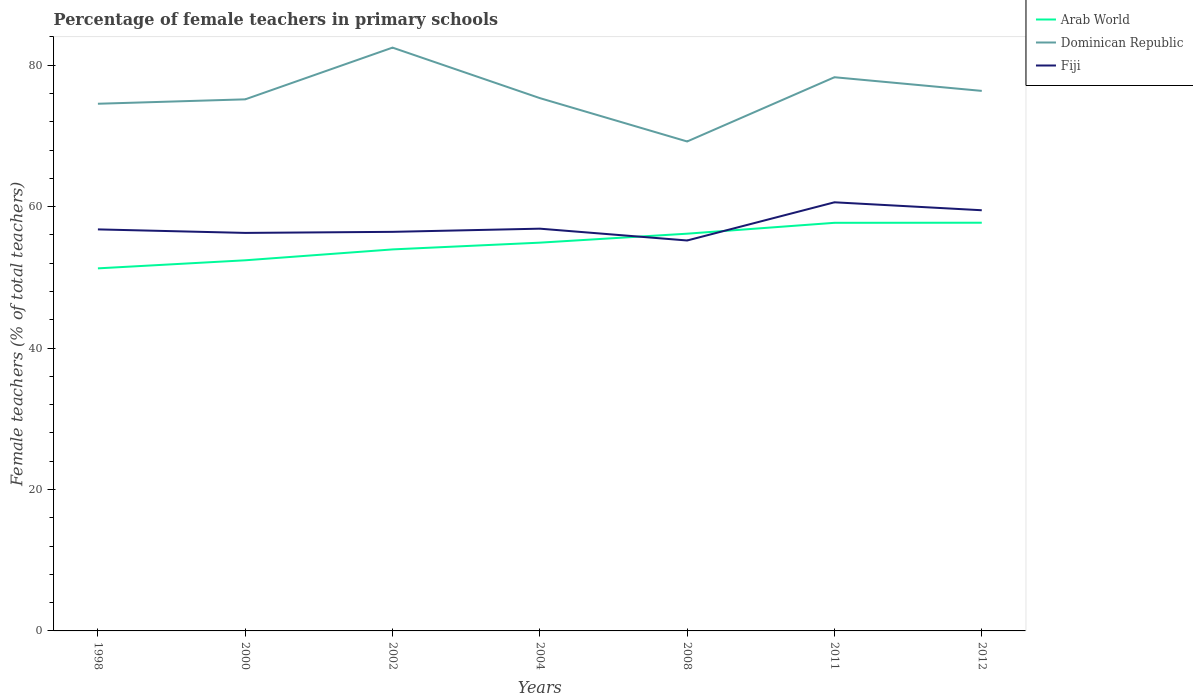How many different coloured lines are there?
Your answer should be compact. 3. Is the number of lines equal to the number of legend labels?
Provide a succinct answer. Yes. Across all years, what is the maximum percentage of female teachers in Arab World?
Make the answer very short. 51.27. In which year was the percentage of female teachers in Dominican Republic maximum?
Your answer should be very brief. 2008. What is the total percentage of female teachers in Dominican Republic in the graph?
Your answer should be very brief. -1.02. What is the difference between the highest and the second highest percentage of female teachers in Fiji?
Make the answer very short. 5.4. Is the percentage of female teachers in Arab World strictly greater than the percentage of female teachers in Dominican Republic over the years?
Make the answer very short. Yes. What is the difference between two consecutive major ticks on the Y-axis?
Offer a very short reply. 20. Does the graph contain any zero values?
Provide a succinct answer. No. Does the graph contain grids?
Your answer should be very brief. No. How many legend labels are there?
Provide a short and direct response. 3. What is the title of the graph?
Your answer should be very brief. Percentage of female teachers in primary schools. Does "Denmark" appear as one of the legend labels in the graph?
Make the answer very short. No. What is the label or title of the X-axis?
Your response must be concise. Years. What is the label or title of the Y-axis?
Your answer should be very brief. Female teachers (% of total teachers). What is the Female teachers (% of total teachers) of Arab World in 1998?
Provide a succinct answer. 51.27. What is the Female teachers (% of total teachers) in Dominican Republic in 1998?
Offer a very short reply. 74.56. What is the Female teachers (% of total teachers) of Fiji in 1998?
Your response must be concise. 56.79. What is the Female teachers (% of total teachers) in Arab World in 2000?
Offer a terse response. 52.42. What is the Female teachers (% of total teachers) of Dominican Republic in 2000?
Provide a succinct answer. 75.18. What is the Female teachers (% of total teachers) in Fiji in 2000?
Your answer should be very brief. 56.29. What is the Female teachers (% of total teachers) in Arab World in 2002?
Your answer should be compact. 53.95. What is the Female teachers (% of total teachers) of Dominican Republic in 2002?
Keep it short and to the point. 82.49. What is the Female teachers (% of total teachers) in Fiji in 2002?
Give a very brief answer. 56.44. What is the Female teachers (% of total teachers) of Arab World in 2004?
Your answer should be compact. 54.91. What is the Female teachers (% of total teachers) of Dominican Republic in 2004?
Provide a short and direct response. 75.35. What is the Female teachers (% of total teachers) of Fiji in 2004?
Provide a succinct answer. 56.89. What is the Female teachers (% of total teachers) in Arab World in 2008?
Offer a very short reply. 56.18. What is the Female teachers (% of total teachers) of Dominican Republic in 2008?
Give a very brief answer. 69.22. What is the Female teachers (% of total teachers) of Fiji in 2008?
Provide a short and direct response. 55.22. What is the Female teachers (% of total teachers) of Arab World in 2011?
Your response must be concise. 57.72. What is the Female teachers (% of total teachers) in Dominican Republic in 2011?
Give a very brief answer. 78.31. What is the Female teachers (% of total teachers) of Fiji in 2011?
Your answer should be very brief. 60.62. What is the Female teachers (% of total teachers) of Arab World in 2012?
Your answer should be very brief. 57.73. What is the Female teachers (% of total teachers) of Dominican Republic in 2012?
Your answer should be compact. 76.37. What is the Female teachers (% of total teachers) of Fiji in 2012?
Provide a succinct answer. 59.49. Across all years, what is the maximum Female teachers (% of total teachers) of Arab World?
Provide a short and direct response. 57.73. Across all years, what is the maximum Female teachers (% of total teachers) of Dominican Republic?
Offer a very short reply. 82.49. Across all years, what is the maximum Female teachers (% of total teachers) in Fiji?
Offer a very short reply. 60.62. Across all years, what is the minimum Female teachers (% of total teachers) of Arab World?
Make the answer very short. 51.27. Across all years, what is the minimum Female teachers (% of total teachers) in Dominican Republic?
Provide a short and direct response. 69.22. Across all years, what is the minimum Female teachers (% of total teachers) in Fiji?
Make the answer very short. 55.22. What is the total Female teachers (% of total teachers) in Arab World in the graph?
Offer a terse response. 384.18. What is the total Female teachers (% of total teachers) of Dominican Republic in the graph?
Give a very brief answer. 531.48. What is the total Female teachers (% of total teachers) in Fiji in the graph?
Keep it short and to the point. 401.73. What is the difference between the Female teachers (% of total teachers) of Arab World in 1998 and that in 2000?
Provide a succinct answer. -1.14. What is the difference between the Female teachers (% of total teachers) of Dominican Republic in 1998 and that in 2000?
Keep it short and to the point. -0.62. What is the difference between the Female teachers (% of total teachers) of Fiji in 1998 and that in 2000?
Give a very brief answer. 0.5. What is the difference between the Female teachers (% of total teachers) of Arab World in 1998 and that in 2002?
Make the answer very short. -2.68. What is the difference between the Female teachers (% of total teachers) in Dominican Republic in 1998 and that in 2002?
Give a very brief answer. -7.94. What is the difference between the Female teachers (% of total teachers) in Fiji in 1998 and that in 2002?
Ensure brevity in your answer.  0.35. What is the difference between the Female teachers (% of total teachers) of Arab World in 1998 and that in 2004?
Offer a very short reply. -3.64. What is the difference between the Female teachers (% of total teachers) of Dominican Republic in 1998 and that in 2004?
Make the answer very short. -0.8. What is the difference between the Female teachers (% of total teachers) in Fiji in 1998 and that in 2004?
Offer a very short reply. -0.1. What is the difference between the Female teachers (% of total teachers) of Arab World in 1998 and that in 2008?
Your response must be concise. -4.9. What is the difference between the Female teachers (% of total teachers) of Dominican Republic in 1998 and that in 2008?
Offer a terse response. 5.34. What is the difference between the Female teachers (% of total teachers) of Fiji in 1998 and that in 2008?
Ensure brevity in your answer.  1.57. What is the difference between the Female teachers (% of total teachers) of Arab World in 1998 and that in 2011?
Keep it short and to the point. -6.44. What is the difference between the Female teachers (% of total teachers) of Dominican Republic in 1998 and that in 2011?
Ensure brevity in your answer.  -3.75. What is the difference between the Female teachers (% of total teachers) of Fiji in 1998 and that in 2011?
Keep it short and to the point. -3.83. What is the difference between the Female teachers (% of total teachers) of Arab World in 1998 and that in 2012?
Give a very brief answer. -6.46. What is the difference between the Female teachers (% of total teachers) of Dominican Republic in 1998 and that in 2012?
Make the answer very short. -1.82. What is the difference between the Female teachers (% of total teachers) in Fiji in 1998 and that in 2012?
Give a very brief answer. -2.71. What is the difference between the Female teachers (% of total teachers) in Arab World in 2000 and that in 2002?
Provide a succinct answer. -1.54. What is the difference between the Female teachers (% of total teachers) in Dominican Republic in 2000 and that in 2002?
Make the answer very short. -7.32. What is the difference between the Female teachers (% of total teachers) of Fiji in 2000 and that in 2002?
Your response must be concise. -0.15. What is the difference between the Female teachers (% of total teachers) in Arab World in 2000 and that in 2004?
Make the answer very short. -2.49. What is the difference between the Female teachers (% of total teachers) of Dominican Republic in 2000 and that in 2004?
Ensure brevity in your answer.  -0.17. What is the difference between the Female teachers (% of total teachers) of Fiji in 2000 and that in 2004?
Offer a very short reply. -0.6. What is the difference between the Female teachers (% of total teachers) in Arab World in 2000 and that in 2008?
Offer a terse response. -3.76. What is the difference between the Female teachers (% of total teachers) in Dominican Republic in 2000 and that in 2008?
Offer a terse response. 5.96. What is the difference between the Female teachers (% of total teachers) of Fiji in 2000 and that in 2008?
Give a very brief answer. 1.07. What is the difference between the Female teachers (% of total teachers) of Arab World in 2000 and that in 2011?
Make the answer very short. -5.3. What is the difference between the Female teachers (% of total teachers) in Dominican Republic in 2000 and that in 2011?
Offer a terse response. -3.13. What is the difference between the Female teachers (% of total teachers) of Fiji in 2000 and that in 2011?
Provide a succinct answer. -4.33. What is the difference between the Female teachers (% of total teachers) in Arab World in 2000 and that in 2012?
Your answer should be very brief. -5.31. What is the difference between the Female teachers (% of total teachers) of Dominican Republic in 2000 and that in 2012?
Keep it short and to the point. -1.2. What is the difference between the Female teachers (% of total teachers) of Fiji in 2000 and that in 2012?
Offer a very short reply. -3.21. What is the difference between the Female teachers (% of total teachers) in Arab World in 2002 and that in 2004?
Your response must be concise. -0.96. What is the difference between the Female teachers (% of total teachers) of Dominican Republic in 2002 and that in 2004?
Give a very brief answer. 7.14. What is the difference between the Female teachers (% of total teachers) in Fiji in 2002 and that in 2004?
Provide a short and direct response. -0.45. What is the difference between the Female teachers (% of total teachers) of Arab World in 2002 and that in 2008?
Give a very brief answer. -2.22. What is the difference between the Female teachers (% of total teachers) in Dominican Republic in 2002 and that in 2008?
Your response must be concise. 13.27. What is the difference between the Female teachers (% of total teachers) in Fiji in 2002 and that in 2008?
Your answer should be very brief. 1.22. What is the difference between the Female teachers (% of total teachers) of Arab World in 2002 and that in 2011?
Your response must be concise. -3.76. What is the difference between the Female teachers (% of total teachers) in Dominican Republic in 2002 and that in 2011?
Your answer should be compact. 4.19. What is the difference between the Female teachers (% of total teachers) in Fiji in 2002 and that in 2011?
Your answer should be compact. -4.18. What is the difference between the Female teachers (% of total teachers) in Arab World in 2002 and that in 2012?
Offer a very short reply. -3.78. What is the difference between the Female teachers (% of total teachers) in Dominican Republic in 2002 and that in 2012?
Offer a terse response. 6.12. What is the difference between the Female teachers (% of total teachers) in Fiji in 2002 and that in 2012?
Provide a succinct answer. -3.05. What is the difference between the Female teachers (% of total teachers) of Arab World in 2004 and that in 2008?
Your answer should be very brief. -1.27. What is the difference between the Female teachers (% of total teachers) of Dominican Republic in 2004 and that in 2008?
Make the answer very short. 6.13. What is the difference between the Female teachers (% of total teachers) in Fiji in 2004 and that in 2008?
Offer a terse response. 1.67. What is the difference between the Female teachers (% of total teachers) of Arab World in 2004 and that in 2011?
Offer a terse response. -2.81. What is the difference between the Female teachers (% of total teachers) in Dominican Republic in 2004 and that in 2011?
Give a very brief answer. -2.95. What is the difference between the Female teachers (% of total teachers) of Fiji in 2004 and that in 2011?
Your answer should be compact. -3.73. What is the difference between the Female teachers (% of total teachers) of Arab World in 2004 and that in 2012?
Your response must be concise. -2.82. What is the difference between the Female teachers (% of total teachers) of Dominican Republic in 2004 and that in 2012?
Keep it short and to the point. -1.02. What is the difference between the Female teachers (% of total teachers) in Fiji in 2004 and that in 2012?
Your answer should be compact. -2.61. What is the difference between the Female teachers (% of total teachers) of Arab World in 2008 and that in 2011?
Offer a terse response. -1.54. What is the difference between the Female teachers (% of total teachers) of Dominican Republic in 2008 and that in 2011?
Offer a terse response. -9.09. What is the difference between the Female teachers (% of total teachers) of Fiji in 2008 and that in 2011?
Make the answer very short. -5.4. What is the difference between the Female teachers (% of total teachers) in Arab World in 2008 and that in 2012?
Make the answer very short. -1.55. What is the difference between the Female teachers (% of total teachers) of Dominican Republic in 2008 and that in 2012?
Offer a terse response. -7.15. What is the difference between the Female teachers (% of total teachers) of Fiji in 2008 and that in 2012?
Keep it short and to the point. -4.28. What is the difference between the Female teachers (% of total teachers) in Arab World in 2011 and that in 2012?
Give a very brief answer. -0.01. What is the difference between the Female teachers (% of total teachers) of Dominican Republic in 2011 and that in 2012?
Your answer should be compact. 1.93. What is the difference between the Female teachers (% of total teachers) in Fiji in 2011 and that in 2012?
Offer a terse response. 1.13. What is the difference between the Female teachers (% of total teachers) in Arab World in 1998 and the Female teachers (% of total teachers) in Dominican Republic in 2000?
Your answer should be compact. -23.9. What is the difference between the Female teachers (% of total teachers) in Arab World in 1998 and the Female teachers (% of total teachers) in Fiji in 2000?
Make the answer very short. -5.01. What is the difference between the Female teachers (% of total teachers) of Dominican Republic in 1998 and the Female teachers (% of total teachers) of Fiji in 2000?
Provide a short and direct response. 18.27. What is the difference between the Female teachers (% of total teachers) in Arab World in 1998 and the Female teachers (% of total teachers) in Dominican Republic in 2002?
Offer a terse response. -31.22. What is the difference between the Female teachers (% of total teachers) of Arab World in 1998 and the Female teachers (% of total teachers) of Fiji in 2002?
Give a very brief answer. -5.17. What is the difference between the Female teachers (% of total teachers) of Dominican Republic in 1998 and the Female teachers (% of total teachers) of Fiji in 2002?
Ensure brevity in your answer.  18.12. What is the difference between the Female teachers (% of total teachers) of Arab World in 1998 and the Female teachers (% of total teachers) of Dominican Republic in 2004?
Offer a very short reply. -24.08. What is the difference between the Female teachers (% of total teachers) in Arab World in 1998 and the Female teachers (% of total teachers) in Fiji in 2004?
Ensure brevity in your answer.  -5.61. What is the difference between the Female teachers (% of total teachers) in Dominican Republic in 1998 and the Female teachers (% of total teachers) in Fiji in 2004?
Ensure brevity in your answer.  17.67. What is the difference between the Female teachers (% of total teachers) of Arab World in 1998 and the Female teachers (% of total teachers) of Dominican Republic in 2008?
Keep it short and to the point. -17.94. What is the difference between the Female teachers (% of total teachers) in Arab World in 1998 and the Female teachers (% of total teachers) in Fiji in 2008?
Give a very brief answer. -3.94. What is the difference between the Female teachers (% of total teachers) of Dominican Republic in 1998 and the Female teachers (% of total teachers) of Fiji in 2008?
Give a very brief answer. 19.34. What is the difference between the Female teachers (% of total teachers) in Arab World in 1998 and the Female teachers (% of total teachers) in Dominican Republic in 2011?
Provide a short and direct response. -27.03. What is the difference between the Female teachers (% of total teachers) of Arab World in 1998 and the Female teachers (% of total teachers) of Fiji in 2011?
Make the answer very short. -9.34. What is the difference between the Female teachers (% of total teachers) of Dominican Republic in 1998 and the Female teachers (% of total teachers) of Fiji in 2011?
Provide a succinct answer. 13.94. What is the difference between the Female teachers (% of total teachers) of Arab World in 1998 and the Female teachers (% of total teachers) of Dominican Republic in 2012?
Your answer should be very brief. -25.1. What is the difference between the Female teachers (% of total teachers) of Arab World in 1998 and the Female teachers (% of total teachers) of Fiji in 2012?
Ensure brevity in your answer.  -8.22. What is the difference between the Female teachers (% of total teachers) in Dominican Republic in 1998 and the Female teachers (% of total teachers) in Fiji in 2012?
Your answer should be compact. 15.06. What is the difference between the Female teachers (% of total teachers) of Arab World in 2000 and the Female teachers (% of total teachers) of Dominican Republic in 2002?
Your answer should be compact. -30.08. What is the difference between the Female teachers (% of total teachers) of Arab World in 2000 and the Female teachers (% of total teachers) of Fiji in 2002?
Make the answer very short. -4.02. What is the difference between the Female teachers (% of total teachers) in Dominican Republic in 2000 and the Female teachers (% of total teachers) in Fiji in 2002?
Your answer should be very brief. 18.74. What is the difference between the Female teachers (% of total teachers) of Arab World in 2000 and the Female teachers (% of total teachers) of Dominican Republic in 2004?
Your answer should be compact. -22.94. What is the difference between the Female teachers (% of total teachers) of Arab World in 2000 and the Female teachers (% of total teachers) of Fiji in 2004?
Give a very brief answer. -4.47. What is the difference between the Female teachers (% of total teachers) of Dominican Republic in 2000 and the Female teachers (% of total teachers) of Fiji in 2004?
Keep it short and to the point. 18.29. What is the difference between the Female teachers (% of total teachers) in Arab World in 2000 and the Female teachers (% of total teachers) in Dominican Republic in 2008?
Offer a very short reply. -16.8. What is the difference between the Female teachers (% of total teachers) of Arab World in 2000 and the Female teachers (% of total teachers) of Fiji in 2008?
Your response must be concise. -2.8. What is the difference between the Female teachers (% of total teachers) of Dominican Republic in 2000 and the Female teachers (% of total teachers) of Fiji in 2008?
Make the answer very short. 19.96. What is the difference between the Female teachers (% of total teachers) of Arab World in 2000 and the Female teachers (% of total teachers) of Dominican Republic in 2011?
Your answer should be compact. -25.89. What is the difference between the Female teachers (% of total teachers) in Arab World in 2000 and the Female teachers (% of total teachers) in Fiji in 2011?
Provide a succinct answer. -8.2. What is the difference between the Female teachers (% of total teachers) of Dominican Republic in 2000 and the Female teachers (% of total teachers) of Fiji in 2011?
Ensure brevity in your answer.  14.56. What is the difference between the Female teachers (% of total teachers) of Arab World in 2000 and the Female teachers (% of total teachers) of Dominican Republic in 2012?
Provide a short and direct response. -23.96. What is the difference between the Female teachers (% of total teachers) in Arab World in 2000 and the Female teachers (% of total teachers) in Fiji in 2012?
Provide a short and direct response. -7.08. What is the difference between the Female teachers (% of total teachers) of Dominican Republic in 2000 and the Female teachers (% of total teachers) of Fiji in 2012?
Make the answer very short. 15.68. What is the difference between the Female teachers (% of total teachers) of Arab World in 2002 and the Female teachers (% of total teachers) of Dominican Republic in 2004?
Your response must be concise. -21.4. What is the difference between the Female teachers (% of total teachers) of Arab World in 2002 and the Female teachers (% of total teachers) of Fiji in 2004?
Your answer should be very brief. -2.93. What is the difference between the Female teachers (% of total teachers) of Dominican Republic in 2002 and the Female teachers (% of total teachers) of Fiji in 2004?
Offer a terse response. 25.61. What is the difference between the Female teachers (% of total teachers) of Arab World in 2002 and the Female teachers (% of total teachers) of Dominican Republic in 2008?
Give a very brief answer. -15.26. What is the difference between the Female teachers (% of total teachers) in Arab World in 2002 and the Female teachers (% of total teachers) in Fiji in 2008?
Keep it short and to the point. -1.26. What is the difference between the Female teachers (% of total teachers) of Dominican Republic in 2002 and the Female teachers (% of total teachers) of Fiji in 2008?
Keep it short and to the point. 27.28. What is the difference between the Female teachers (% of total teachers) of Arab World in 2002 and the Female teachers (% of total teachers) of Dominican Republic in 2011?
Offer a terse response. -24.35. What is the difference between the Female teachers (% of total teachers) of Arab World in 2002 and the Female teachers (% of total teachers) of Fiji in 2011?
Provide a succinct answer. -6.66. What is the difference between the Female teachers (% of total teachers) in Dominican Republic in 2002 and the Female teachers (% of total teachers) in Fiji in 2011?
Make the answer very short. 21.88. What is the difference between the Female teachers (% of total teachers) in Arab World in 2002 and the Female teachers (% of total teachers) in Dominican Republic in 2012?
Provide a short and direct response. -22.42. What is the difference between the Female teachers (% of total teachers) of Arab World in 2002 and the Female teachers (% of total teachers) of Fiji in 2012?
Your response must be concise. -5.54. What is the difference between the Female teachers (% of total teachers) in Dominican Republic in 2002 and the Female teachers (% of total teachers) in Fiji in 2012?
Offer a terse response. 23. What is the difference between the Female teachers (% of total teachers) in Arab World in 2004 and the Female teachers (% of total teachers) in Dominican Republic in 2008?
Provide a short and direct response. -14.31. What is the difference between the Female teachers (% of total teachers) of Arab World in 2004 and the Female teachers (% of total teachers) of Fiji in 2008?
Your response must be concise. -0.31. What is the difference between the Female teachers (% of total teachers) in Dominican Republic in 2004 and the Female teachers (% of total teachers) in Fiji in 2008?
Keep it short and to the point. 20.13. What is the difference between the Female teachers (% of total teachers) of Arab World in 2004 and the Female teachers (% of total teachers) of Dominican Republic in 2011?
Provide a short and direct response. -23.4. What is the difference between the Female teachers (% of total teachers) in Arab World in 2004 and the Female teachers (% of total teachers) in Fiji in 2011?
Offer a terse response. -5.71. What is the difference between the Female teachers (% of total teachers) of Dominican Republic in 2004 and the Female teachers (% of total teachers) of Fiji in 2011?
Your answer should be very brief. 14.73. What is the difference between the Female teachers (% of total teachers) in Arab World in 2004 and the Female teachers (% of total teachers) in Dominican Republic in 2012?
Your response must be concise. -21.46. What is the difference between the Female teachers (% of total teachers) in Arab World in 2004 and the Female teachers (% of total teachers) in Fiji in 2012?
Your answer should be compact. -4.58. What is the difference between the Female teachers (% of total teachers) in Dominican Republic in 2004 and the Female teachers (% of total teachers) in Fiji in 2012?
Give a very brief answer. 15.86. What is the difference between the Female teachers (% of total teachers) in Arab World in 2008 and the Female teachers (% of total teachers) in Dominican Republic in 2011?
Make the answer very short. -22.13. What is the difference between the Female teachers (% of total teachers) in Arab World in 2008 and the Female teachers (% of total teachers) in Fiji in 2011?
Ensure brevity in your answer.  -4.44. What is the difference between the Female teachers (% of total teachers) in Dominican Republic in 2008 and the Female teachers (% of total teachers) in Fiji in 2011?
Keep it short and to the point. 8.6. What is the difference between the Female teachers (% of total teachers) of Arab World in 2008 and the Female teachers (% of total teachers) of Dominican Republic in 2012?
Keep it short and to the point. -20.2. What is the difference between the Female teachers (% of total teachers) of Arab World in 2008 and the Female teachers (% of total teachers) of Fiji in 2012?
Offer a very short reply. -3.31. What is the difference between the Female teachers (% of total teachers) of Dominican Republic in 2008 and the Female teachers (% of total teachers) of Fiji in 2012?
Make the answer very short. 9.73. What is the difference between the Female teachers (% of total teachers) of Arab World in 2011 and the Female teachers (% of total teachers) of Dominican Republic in 2012?
Provide a succinct answer. -18.66. What is the difference between the Female teachers (% of total teachers) in Arab World in 2011 and the Female teachers (% of total teachers) in Fiji in 2012?
Your answer should be compact. -1.78. What is the difference between the Female teachers (% of total teachers) in Dominican Republic in 2011 and the Female teachers (% of total teachers) in Fiji in 2012?
Make the answer very short. 18.81. What is the average Female teachers (% of total teachers) of Arab World per year?
Give a very brief answer. 54.88. What is the average Female teachers (% of total teachers) of Dominican Republic per year?
Provide a short and direct response. 75.93. What is the average Female teachers (% of total teachers) of Fiji per year?
Provide a succinct answer. 57.39. In the year 1998, what is the difference between the Female teachers (% of total teachers) in Arab World and Female teachers (% of total teachers) in Dominican Republic?
Ensure brevity in your answer.  -23.28. In the year 1998, what is the difference between the Female teachers (% of total teachers) of Arab World and Female teachers (% of total teachers) of Fiji?
Your answer should be very brief. -5.51. In the year 1998, what is the difference between the Female teachers (% of total teachers) in Dominican Republic and Female teachers (% of total teachers) in Fiji?
Make the answer very short. 17.77. In the year 2000, what is the difference between the Female teachers (% of total teachers) of Arab World and Female teachers (% of total teachers) of Dominican Republic?
Offer a terse response. -22.76. In the year 2000, what is the difference between the Female teachers (% of total teachers) of Arab World and Female teachers (% of total teachers) of Fiji?
Your answer should be compact. -3.87. In the year 2000, what is the difference between the Female teachers (% of total teachers) in Dominican Republic and Female teachers (% of total teachers) in Fiji?
Make the answer very short. 18.89. In the year 2002, what is the difference between the Female teachers (% of total teachers) of Arab World and Female teachers (% of total teachers) of Dominican Republic?
Make the answer very short. -28.54. In the year 2002, what is the difference between the Female teachers (% of total teachers) of Arab World and Female teachers (% of total teachers) of Fiji?
Your answer should be very brief. -2.49. In the year 2002, what is the difference between the Female teachers (% of total teachers) in Dominican Republic and Female teachers (% of total teachers) in Fiji?
Offer a terse response. 26.05. In the year 2004, what is the difference between the Female teachers (% of total teachers) of Arab World and Female teachers (% of total teachers) of Dominican Republic?
Make the answer very short. -20.44. In the year 2004, what is the difference between the Female teachers (% of total teachers) of Arab World and Female teachers (% of total teachers) of Fiji?
Your response must be concise. -1.98. In the year 2004, what is the difference between the Female teachers (% of total teachers) of Dominican Republic and Female teachers (% of total teachers) of Fiji?
Your response must be concise. 18.46. In the year 2008, what is the difference between the Female teachers (% of total teachers) of Arab World and Female teachers (% of total teachers) of Dominican Republic?
Provide a succinct answer. -13.04. In the year 2008, what is the difference between the Female teachers (% of total teachers) of Arab World and Female teachers (% of total teachers) of Fiji?
Make the answer very short. 0.96. In the year 2008, what is the difference between the Female teachers (% of total teachers) in Dominican Republic and Female teachers (% of total teachers) in Fiji?
Your answer should be very brief. 14. In the year 2011, what is the difference between the Female teachers (% of total teachers) in Arab World and Female teachers (% of total teachers) in Dominican Republic?
Your answer should be compact. -20.59. In the year 2011, what is the difference between the Female teachers (% of total teachers) of Arab World and Female teachers (% of total teachers) of Fiji?
Give a very brief answer. -2.9. In the year 2011, what is the difference between the Female teachers (% of total teachers) of Dominican Republic and Female teachers (% of total teachers) of Fiji?
Offer a terse response. 17.69. In the year 2012, what is the difference between the Female teachers (% of total teachers) of Arab World and Female teachers (% of total teachers) of Dominican Republic?
Your response must be concise. -18.64. In the year 2012, what is the difference between the Female teachers (% of total teachers) in Arab World and Female teachers (% of total teachers) in Fiji?
Ensure brevity in your answer.  -1.76. In the year 2012, what is the difference between the Female teachers (% of total teachers) in Dominican Republic and Female teachers (% of total teachers) in Fiji?
Keep it short and to the point. 16.88. What is the ratio of the Female teachers (% of total teachers) in Arab World in 1998 to that in 2000?
Ensure brevity in your answer.  0.98. What is the ratio of the Female teachers (% of total teachers) of Fiji in 1998 to that in 2000?
Your response must be concise. 1.01. What is the ratio of the Female teachers (% of total teachers) in Arab World in 1998 to that in 2002?
Provide a succinct answer. 0.95. What is the ratio of the Female teachers (% of total teachers) in Dominican Republic in 1998 to that in 2002?
Your answer should be compact. 0.9. What is the ratio of the Female teachers (% of total teachers) of Fiji in 1998 to that in 2002?
Provide a short and direct response. 1.01. What is the ratio of the Female teachers (% of total teachers) in Arab World in 1998 to that in 2004?
Your response must be concise. 0.93. What is the ratio of the Female teachers (% of total teachers) of Dominican Republic in 1998 to that in 2004?
Offer a very short reply. 0.99. What is the ratio of the Female teachers (% of total teachers) in Fiji in 1998 to that in 2004?
Provide a succinct answer. 1. What is the ratio of the Female teachers (% of total teachers) in Arab World in 1998 to that in 2008?
Your answer should be very brief. 0.91. What is the ratio of the Female teachers (% of total teachers) of Dominican Republic in 1998 to that in 2008?
Your answer should be very brief. 1.08. What is the ratio of the Female teachers (% of total teachers) in Fiji in 1998 to that in 2008?
Your answer should be compact. 1.03. What is the ratio of the Female teachers (% of total teachers) of Arab World in 1998 to that in 2011?
Offer a terse response. 0.89. What is the ratio of the Female teachers (% of total teachers) in Dominican Republic in 1998 to that in 2011?
Make the answer very short. 0.95. What is the ratio of the Female teachers (% of total teachers) of Fiji in 1998 to that in 2011?
Your response must be concise. 0.94. What is the ratio of the Female teachers (% of total teachers) in Arab World in 1998 to that in 2012?
Ensure brevity in your answer.  0.89. What is the ratio of the Female teachers (% of total teachers) in Dominican Republic in 1998 to that in 2012?
Offer a very short reply. 0.98. What is the ratio of the Female teachers (% of total teachers) in Fiji in 1998 to that in 2012?
Your response must be concise. 0.95. What is the ratio of the Female teachers (% of total teachers) of Arab World in 2000 to that in 2002?
Make the answer very short. 0.97. What is the ratio of the Female teachers (% of total teachers) in Dominican Republic in 2000 to that in 2002?
Your response must be concise. 0.91. What is the ratio of the Female teachers (% of total teachers) in Arab World in 2000 to that in 2004?
Offer a terse response. 0.95. What is the ratio of the Female teachers (% of total teachers) in Dominican Republic in 2000 to that in 2004?
Provide a succinct answer. 1. What is the ratio of the Female teachers (% of total teachers) of Fiji in 2000 to that in 2004?
Provide a succinct answer. 0.99. What is the ratio of the Female teachers (% of total teachers) in Arab World in 2000 to that in 2008?
Make the answer very short. 0.93. What is the ratio of the Female teachers (% of total teachers) in Dominican Republic in 2000 to that in 2008?
Provide a succinct answer. 1.09. What is the ratio of the Female teachers (% of total teachers) of Fiji in 2000 to that in 2008?
Make the answer very short. 1.02. What is the ratio of the Female teachers (% of total teachers) of Arab World in 2000 to that in 2011?
Offer a terse response. 0.91. What is the ratio of the Female teachers (% of total teachers) of Dominican Republic in 2000 to that in 2011?
Provide a short and direct response. 0.96. What is the ratio of the Female teachers (% of total teachers) in Arab World in 2000 to that in 2012?
Ensure brevity in your answer.  0.91. What is the ratio of the Female teachers (% of total teachers) in Dominican Republic in 2000 to that in 2012?
Your response must be concise. 0.98. What is the ratio of the Female teachers (% of total teachers) of Fiji in 2000 to that in 2012?
Your answer should be very brief. 0.95. What is the ratio of the Female teachers (% of total teachers) of Arab World in 2002 to that in 2004?
Keep it short and to the point. 0.98. What is the ratio of the Female teachers (% of total teachers) of Dominican Republic in 2002 to that in 2004?
Make the answer very short. 1.09. What is the ratio of the Female teachers (% of total teachers) of Arab World in 2002 to that in 2008?
Offer a very short reply. 0.96. What is the ratio of the Female teachers (% of total teachers) in Dominican Republic in 2002 to that in 2008?
Your response must be concise. 1.19. What is the ratio of the Female teachers (% of total teachers) of Fiji in 2002 to that in 2008?
Your answer should be compact. 1.02. What is the ratio of the Female teachers (% of total teachers) of Arab World in 2002 to that in 2011?
Ensure brevity in your answer.  0.93. What is the ratio of the Female teachers (% of total teachers) in Dominican Republic in 2002 to that in 2011?
Provide a succinct answer. 1.05. What is the ratio of the Female teachers (% of total teachers) of Fiji in 2002 to that in 2011?
Provide a succinct answer. 0.93. What is the ratio of the Female teachers (% of total teachers) in Arab World in 2002 to that in 2012?
Offer a very short reply. 0.93. What is the ratio of the Female teachers (% of total teachers) in Dominican Republic in 2002 to that in 2012?
Provide a short and direct response. 1.08. What is the ratio of the Female teachers (% of total teachers) of Fiji in 2002 to that in 2012?
Offer a terse response. 0.95. What is the ratio of the Female teachers (% of total teachers) in Arab World in 2004 to that in 2008?
Your response must be concise. 0.98. What is the ratio of the Female teachers (% of total teachers) of Dominican Republic in 2004 to that in 2008?
Your answer should be compact. 1.09. What is the ratio of the Female teachers (% of total teachers) of Fiji in 2004 to that in 2008?
Keep it short and to the point. 1.03. What is the ratio of the Female teachers (% of total teachers) in Arab World in 2004 to that in 2011?
Give a very brief answer. 0.95. What is the ratio of the Female teachers (% of total teachers) in Dominican Republic in 2004 to that in 2011?
Your answer should be compact. 0.96. What is the ratio of the Female teachers (% of total teachers) of Fiji in 2004 to that in 2011?
Ensure brevity in your answer.  0.94. What is the ratio of the Female teachers (% of total teachers) of Arab World in 2004 to that in 2012?
Make the answer very short. 0.95. What is the ratio of the Female teachers (% of total teachers) in Dominican Republic in 2004 to that in 2012?
Offer a terse response. 0.99. What is the ratio of the Female teachers (% of total teachers) of Fiji in 2004 to that in 2012?
Your answer should be very brief. 0.96. What is the ratio of the Female teachers (% of total teachers) in Arab World in 2008 to that in 2011?
Your answer should be very brief. 0.97. What is the ratio of the Female teachers (% of total teachers) of Dominican Republic in 2008 to that in 2011?
Provide a short and direct response. 0.88. What is the ratio of the Female teachers (% of total teachers) of Fiji in 2008 to that in 2011?
Your answer should be compact. 0.91. What is the ratio of the Female teachers (% of total teachers) in Arab World in 2008 to that in 2012?
Keep it short and to the point. 0.97. What is the ratio of the Female teachers (% of total teachers) of Dominican Republic in 2008 to that in 2012?
Your answer should be compact. 0.91. What is the ratio of the Female teachers (% of total teachers) of Fiji in 2008 to that in 2012?
Make the answer very short. 0.93. What is the ratio of the Female teachers (% of total teachers) of Arab World in 2011 to that in 2012?
Offer a very short reply. 1. What is the ratio of the Female teachers (% of total teachers) in Dominican Republic in 2011 to that in 2012?
Offer a terse response. 1.03. What is the ratio of the Female teachers (% of total teachers) of Fiji in 2011 to that in 2012?
Keep it short and to the point. 1.02. What is the difference between the highest and the second highest Female teachers (% of total teachers) of Arab World?
Your answer should be compact. 0.01. What is the difference between the highest and the second highest Female teachers (% of total teachers) of Dominican Republic?
Your answer should be compact. 4.19. What is the difference between the highest and the second highest Female teachers (% of total teachers) in Fiji?
Provide a short and direct response. 1.13. What is the difference between the highest and the lowest Female teachers (% of total teachers) of Arab World?
Give a very brief answer. 6.46. What is the difference between the highest and the lowest Female teachers (% of total teachers) in Dominican Republic?
Your response must be concise. 13.27. What is the difference between the highest and the lowest Female teachers (% of total teachers) of Fiji?
Keep it short and to the point. 5.4. 